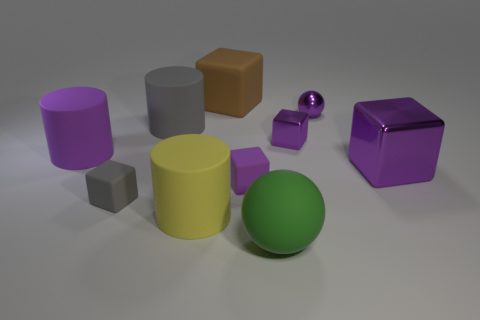Subtract all purple blocks. How many were subtracted if there are1purple blocks left? 2 Subtract all purple balls. How many purple cubes are left? 3 Subtract all large brown matte cubes. How many cubes are left? 4 Subtract all gray blocks. How many blocks are left? 4 Subtract all green blocks. Subtract all purple cylinders. How many blocks are left? 5 Subtract all cylinders. How many objects are left? 7 Subtract 1 purple spheres. How many objects are left? 9 Subtract all small purple balls. Subtract all large blue rubber things. How many objects are left? 9 Add 1 purple shiny objects. How many purple shiny objects are left? 4 Add 5 large gray matte cylinders. How many large gray matte cylinders exist? 6 